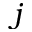Convert formula to latex. <formula><loc_0><loc_0><loc_500><loc_500>j</formula> 